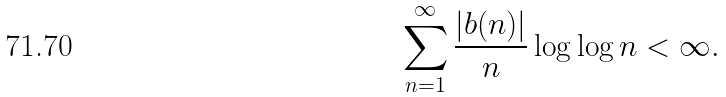<formula> <loc_0><loc_0><loc_500><loc_500>\sum _ { n = 1 } ^ { \infty } \frac { | b ( n ) | } { n } \log \log n < \infty .</formula> 